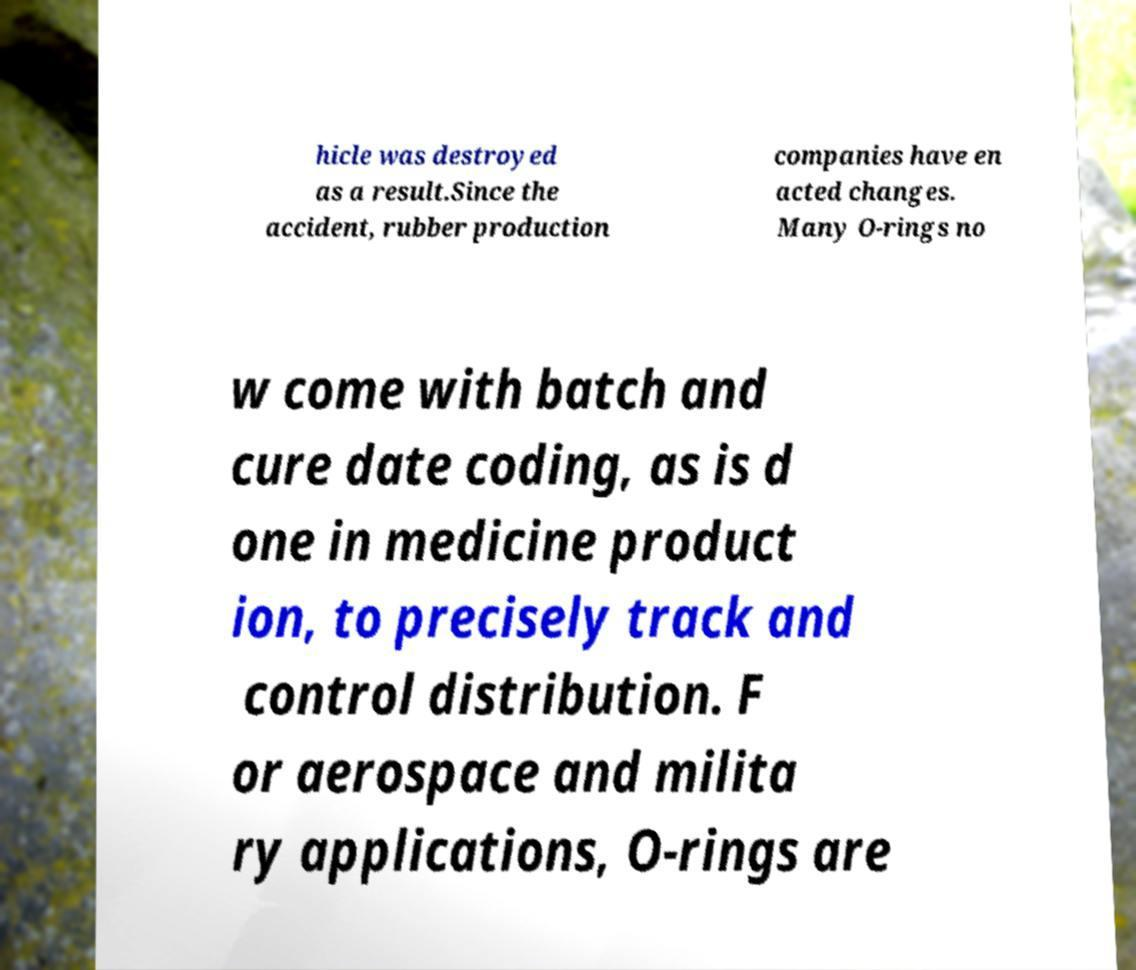What messages or text are displayed in this image? I need them in a readable, typed format. hicle was destroyed as a result.Since the accident, rubber production companies have en acted changes. Many O-rings no w come with batch and cure date coding, as is d one in medicine product ion, to precisely track and control distribution. F or aerospace and milita ry applications, O-rings are 